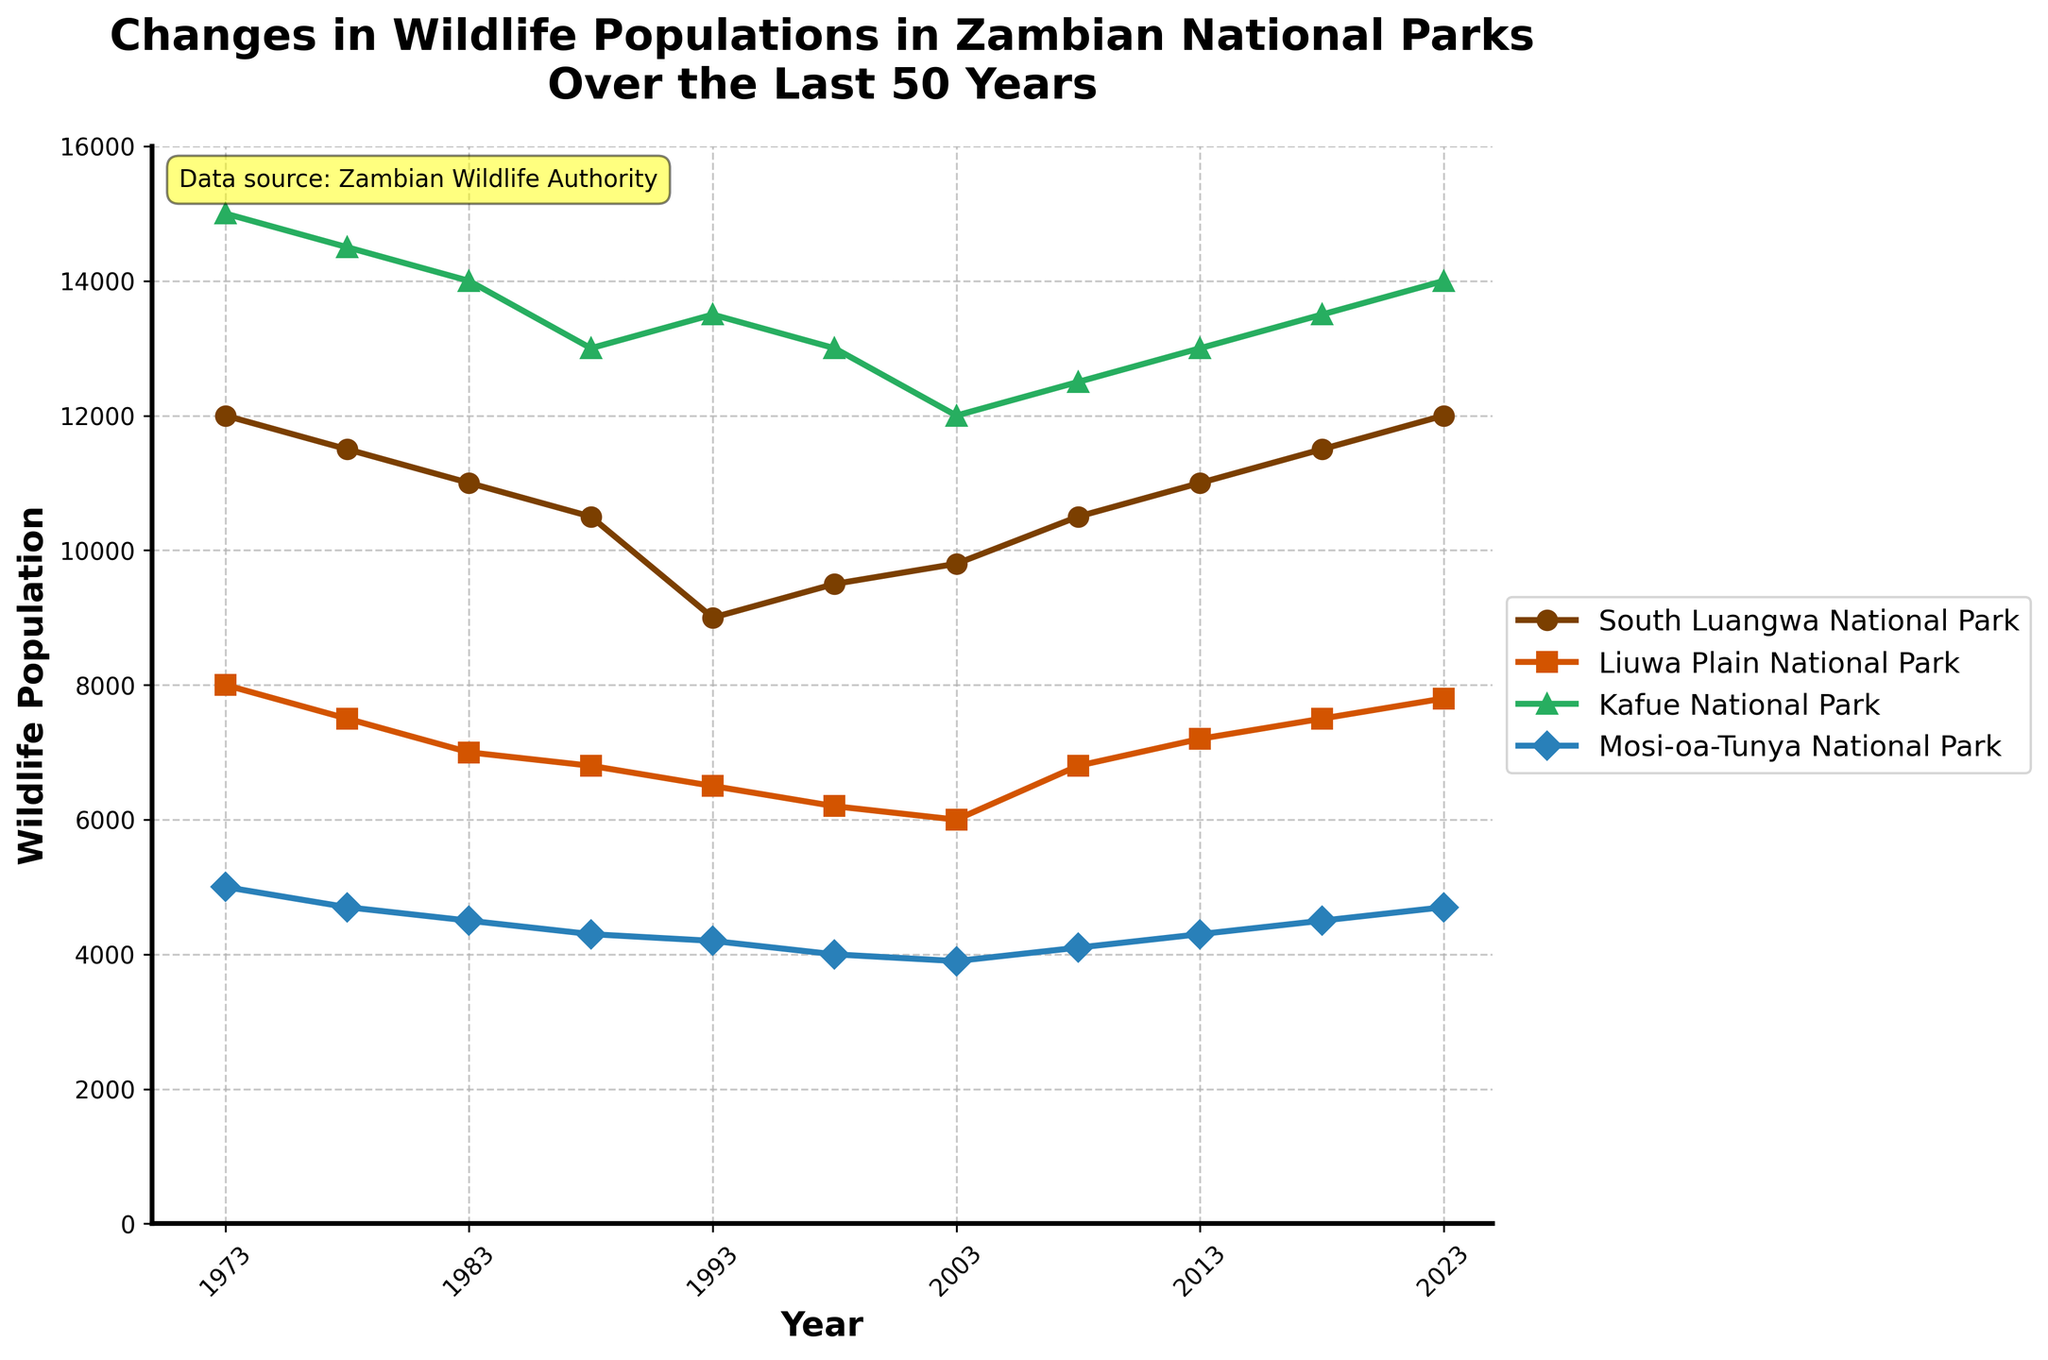What's the title of the figure? The title of the figure is found at the top of the chart.
Answer: Changes in Wildlife Populations in Zambian National Parks Over the Last 50 Years What is the y-axis measuring? The y-axis shows the measure being tracked over time, usually labeled near the axis.
Answer: Wildlife Population Which national park had the highest wildlife population in 2023? Look at the endpoints of the lines for the most recent year (2023) and see which line reaches the highest value on the y-axis.
Answer: Kafue National Park Which national park had the lowest wildlife population in 1973? Look at the endpoints of each line for 1973 to identify the lowest value on the y-axis.
Answer: Mosi-oa-Tunya National Park By how much did the wildlife population in Liuwa Plain National Park change between 1993 and 2023? Subtract the wildlife population of Liuwa Plain National Park in 1993 from its population in 2023: 7800 - 6500 = 1300
Answer: 1300 How does the wildlife population trend in South Luangwa National Park compare to that in Kafue National Park over the 50 years? Observe the lines representing South Luangwa and Kafue National Parks. Note the general direction and changes over time for both parks.
Answer: South Luangwa remained more stable; Kafue saw more fluctuation Which national park experienced the most significant decline in wildlife population from 1973 to 1993? Calculate the difference between the 1973 and 1993 values for each park, identify the largest negative difference.
Answer: South Luangwa National Park In which year did the Mosi-oa-Tunya National Park reach its lowest wildlife population? Look for the lowest point on the line for Mosi-oa-Tunya National Park and note the corresponding year on the x-axis.
Answer: 2003 What's the average wildlife population of Kafue National Park over the 50 years? Add up all the wildlife populations of Kafue National Park for each year and divide by the number of data points (11). (15000 + 14500 + 14000 + 13000 + 13500 + 13000 + 12000 + 12500 + 13000 + 13500 + 14000)/11
Answer: 13,045 Compare the wildlife population in South Luangwa National Park in 1973 with that in 2023. Look at the values for South Luangwa National Park in 1973 and 2023. Note how these values differ.
Answer: Both are 12,000; no change 